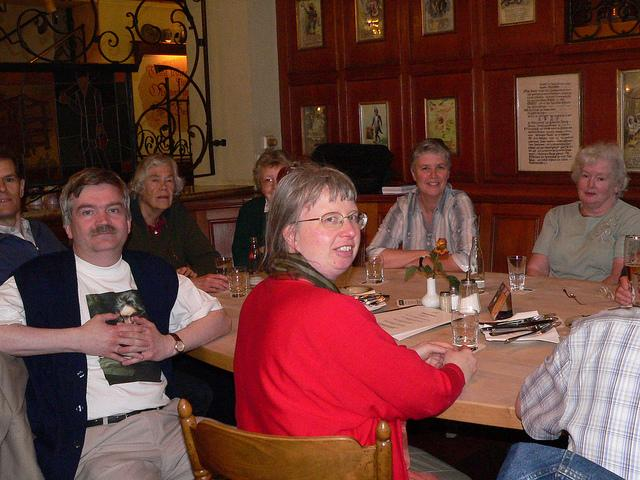What age class do most people here belong to? Please explain your reasoning. seniors. Most of the people seen look like they are senior citizens. 